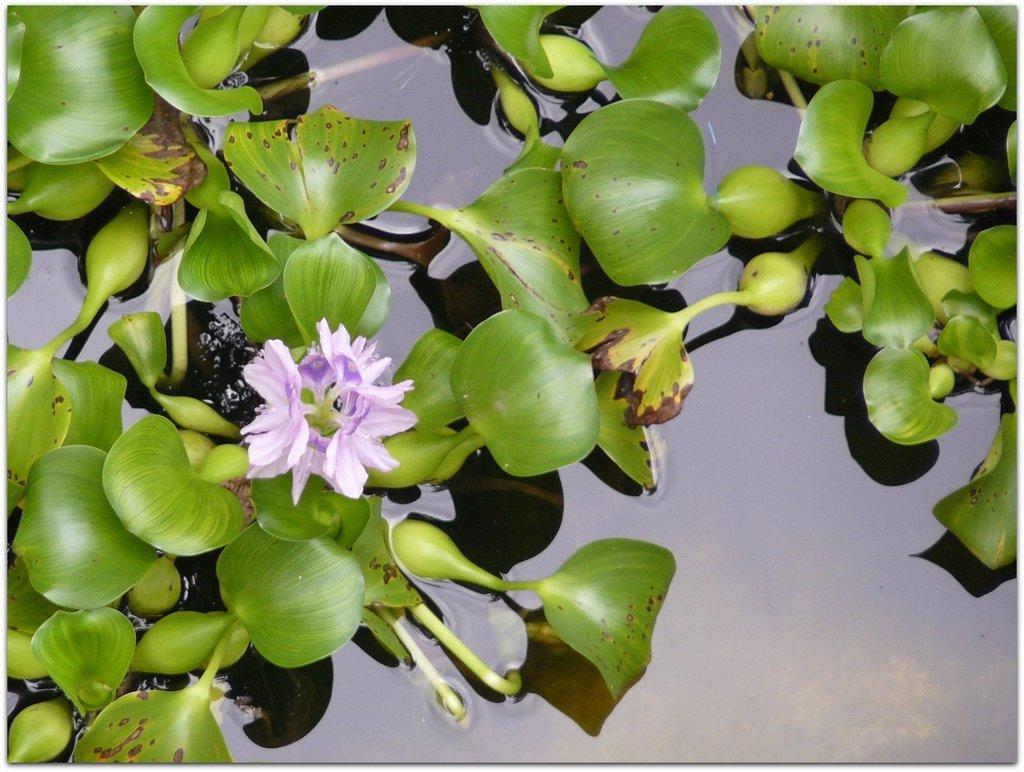In one or two sentences, can you explain what this image depicts? In this image we can see the flowers, leaves and also the water. 